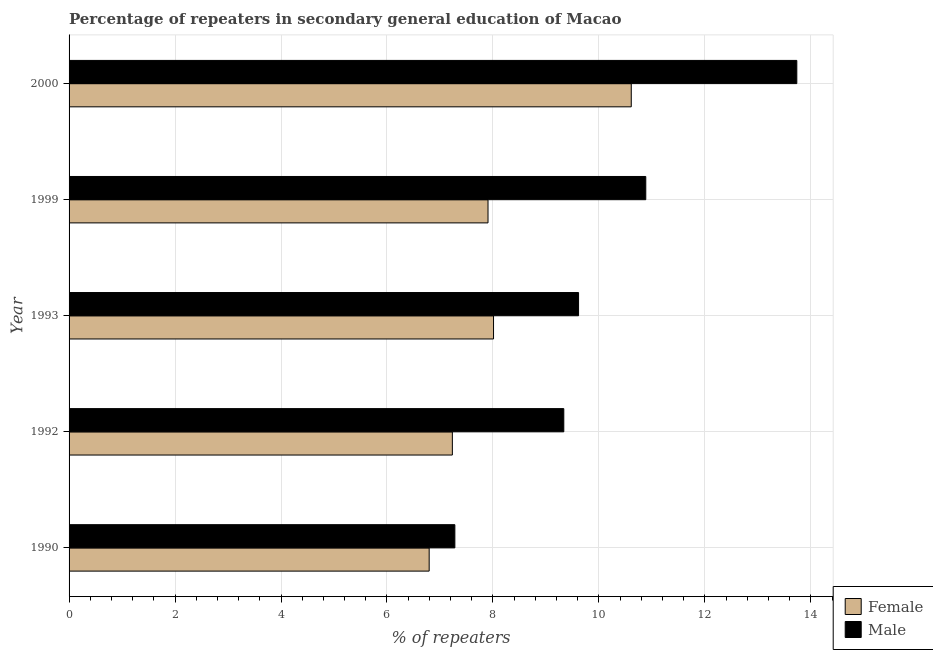How many bars are there on the 1st tick from the bottom?
Provide a short and direct response. 2. What is the percentage of male repeaters in 1990?
Provide a short and direct response. 7.28. Across all years, what is the maximum percentage of female repeaters?
Your answer should be compact. 10.61. Across all years, what is the minimum percentage of female repeaters?
Ensure brevity in your answer.  6.8. In which year was the percentage of male repeaters minimum?
Your response must be concise. 1990. What is the total percentage of male repeaters in the graph?
Your response must be concise. 50.86. What is the difference between the percentage of female repeaters in 1990 and that in 1993?
Your answer should be compact. -1.22. What is the difference between the percentage of male repeaters in 2000 and the percentage of female repeaters in 1992?
Give a very brief answer. 6.5. What is the average percentage of male repeaters per year?
Offer a terse response. 10.17. In the year 2000, what is the difference between the percentage of male repeaters and percentage of female repeaters?
Keep it short and to the point. 3.12. What is the ratio of the percentage of female repeaters in 1992 to that in 1993?
Your response must be concise. 0.9. Is the percentage of male repeaters in 1999 less than that in 2000?
Give a very brief answer. Yes. What is the difference between the highest and the second highest percentage of female repeaters?
Keep it short and to the point. 2.6. What is the difference between the highest and the lowest percentage of female repeaters?
Your response must be concise. 3.81. Is the sum of the percentage of male repeaters in 1992 and 1999 greater than the maximum percentage of female repeaters across all years?
Offer a terse response. Yes. How many bars are there?
Give a very brief answer. 10. How many years are there in the graph?
Provide a succinct answer. 5. What is the difference between two consecutive major ticks on the X-axis?
Provide a short and direct response. 2. Does the graph contain grids?
Your answer should be compact. Yes. How are the legend labels stacked?
Make the answer very short. Vertical. What is the title of the graph?
Keep it short and to the point. Percentage of repeaters in secondary general education of Macao. Does "Female" appear as one of the legend labels in the graph?
Your response must be concise. Yes. What is the label or title of the X-axis?
Your answer should be very brief. % of repeaters. What is the label or title of the Y-axis?
Ensure brevity in your answer.  Year. What is the % of repeaters of Female in 1990?
Offer a very short reply. 6.8. What is the % of repeaters in Male in 1990?
Keep it short and to the point. 7.28. What is the % of repeaters in Female in 1992?
Ensure brevity in your answer.  7.23. What is the % of repeaters in Male in 1992?
Your response must be concise. 9.34. What is the % of repeaters in Female in 1993?
Your response must be concise. 8.01. What is the % of repeaters in Male in 1993?
Give a very brief answer. 9.62. What is the % of repeaters in Female in 1999?
Your answer should be very brief. 7.91. What is the % of repeaters in Male in 1999?
Provide a short and direct response. 10.89. What is the % of repeaters in Female in 2000?
Keep it short and to the point. 10.61. What is the % of repeaters in Male in 2000?
Keep it short and to the point. 13.74. Across all years, what is the maximum % of repeaters in Female?
Keep it short and to the point. 10.61. Across all years, what is the maximum % of repeaters in Male?
Give a very brief answer. 13.74. Across all years, what is the minimum % of repeaters of Female?
Keep it short and to the point. 6.8. Across all years, what is the minimum % of repeaters of Male?
Keep it short and to the point. 7.28. What is the total % of repeaters of Female in the graph?
Your answer should be compact. 40.56. What is the total % of repeaters of Male in the graph?
Keep it short and to the point. 50.86. What is the difference between the % of repeaters in Female in 1990 and that in 1992?
Your response must be concise. -0.44. What is the difference between the % of repeaters in Male in 1990 and that in 1992?
Your answer should be very brief. -2.06. What is the difference between the % of repeaters in Female in 1990 and that in 1993?
Provide a succinct answer. -1.21. What is the difference between the % of repeaters in Male in 1990 and that in 1993?
Ensure brevity in your answer.  -2.33. What is the difference between the % of repeaters in Female in 1990 and that in 1999?
Ensure brevity in your answer.  -1.11. What is the difference between the % of repeaters in Male in 1990 and that in 1999?
Offer a terse response. -3.6. What is the difference between the % of repeaters of Female in 1990 and that in 2000?
Offer a terse response. -3.81. What is the difference between the % of repeaters in Male in 1990 and that in 2000?
Offer a terse response. -6.45. What is the difference between the % of repeaters in Female in 1992 and that in 1993?
Provide a short and direct response. -0.78. What is the difference between the % of repeaters of Male in 1992 and that in 1993?
Your answer should be compact. -0.28. What is the difference between the % of repeaters of Female in 1992 and that in 1999?
Your answer should be very brief. -0.67. What is the difference between the % of repeaters in Male in 1992 and that in 1999?
Your answer should be very brief. -1.55. What is the difference between the % of repeaters in Female in 1992 and that in 2000?
Your answer should be very brief. -3.38. What is the difference between the % of repeaters in Male in 1992 and that in 2000?
Give a very brief answer. -4.4. What is the difference between the % of repeaters of Female in 1993 and that in 1999?
Make the answer very short. 0.1. What is the difference between the % of repeaters in Male in 1993 and that in 1999?
Give a very brief answer. -1.27. What is the difference between the % of repeaters of Female in 1993 and that in 2000?
Your answer should be compact. -2.6. What is the difference between the % of repeaters in Male in 1993 and that in 2000?
Your answer should be compact. -4.12. What is the difference between the % of repeaters in Female in 1999 and that in 2000?
Give a very brief answer. -2.7. What is the difference between the % of repeaters in Male in 1999 and that in 2000?
Offer a very short reply. -2.85. What is the difference between the % of repeaters of Female in 1990 and the % of repeaters of Male in 1992?
Provide a short and direct response. -2.54. What is the difference between the % of repeaters of Female in 1990 and the % of repeaters of Male in 1993?
Your answer should be very brief. -2.82. What is the difference between the % of repeaters in Female in 1990 and the % of repeaters in Male in 1999?
Offer a very short reply. -4.09. What is the difference between the % of repeaters of Female in 1990 and the % of repeaters of Male in 2000?
Make the answer very short. -6.94. What is the difference between the % of repeaters in Female in 1992 and the % of repeaters in Male in 1993?
Your answer should be compact. -2.38. What is the difference between the % of repeaters in Female in 1992 and the % of repeaters in Male in 1999?
Your answer should be very brief. -3.65. What is the difference between the % of repeaters of Female in 1992 and the % of repeaters of Male in 2000?
Your response must be concise. -6.5. What is the difference between the % of repeaters in Female in 1993 and the % of repeaters in Male in 1999?
Offer a very short reply. -2.87. What is the difference between the % of repeaters in Female in 1993 and the % of repeaters in Male in 2000?
Your answer should be very brief. -5.72. What is the difference between the % of repeaters of Female in 1999 and the % of repeaters of Male in 2000?
Make the answer very short. -5.83. What is the average % of repeaters in Female per year?
Your answer should be compact. 8.11. What is the average % of repeaters of Male per year?
Offer a terse response. 10.17. In the year 1990, what is the difference between the % of repeaters in Female and % of repeaters in Male?
Make the answer very short. -0.48. In the year 1992, what is the difference between the % of repeaters of Female and % of repeaters of Male?
Offer a terse response. -2.1. In the year 1993, what is the difference between the % of repeaters in Female and % of repeaters in Male?
Provide a succinct answer. -1.61. In the year 1999, what is the difference between the % of repeaters in Female and % of repeaters in Male?
Offer a very short reply. -2.98. In the year 2000, what is the difference between the % of repeaters of Female and % of repeaters of Male?
Provide a short and direct response. -3.12. What is the ratio of the % of repeaters of Female in 1990 to that in 1992?
Provide a succinct answer. 0.94. What is the ratio of the % of repeaters of Male in 1990 to that in 1992?
Give a very brief answer. 0.78. What is the ratio of the % of repeaters of Female in 1990 to that in 1993?
Make the answer very short. 0.85. What is the ratio of the % of repeaters in Male in 1990 to that in 1993?
Offer a very short reply. 0.76. What is the ratio of the % of repeaters in Female in 1990 to that in 1999?
Provide a short and direct response. 0.86. What is the ratio of the % of repeaters of Male in 1990 to that in 1999?
Provide a short and direct response. 0.67. What is the ratio of the % of repeaters in Female in 1990 to that in 2000?
Your response must be concise. 0.64. What is the ratio of the % of repeaters of Male in 1990 to that in 2000?
Offer a terse response. 0.53. What is the ratio of the % of repeaters of Female in 1992 to that in 1993?
Give a very brief answer. 0.9. What is the ratio of the % of repeaters in Male in 1992 to that in 1993?
Ensure brevity in your answer.  0.97. What is the ratio of the % of repeaters in Female in 1992 to that in 1999?
Your answer should be very brief. 0.91. What is the ratio of the % of repeaters of Male in 1992 to that in 1999?
Offer a very short reply. 0.86. What is the ratio of the % of repeaters of Female in 1992 to that in 2000?
Provide a short and direct response. 0.68. What is the ratio of the % of repeaters of Male in 1992 to that in 2000?
Provide a short and direct response. 0.68. What is the ratio of the % of repeaters of Female in 1993 to that in 1999?
Give a very brief answer. 1.01. What is the ratio of the % of repeaters of Male in 1993 to that in 1999?
Offer a very short reply. 0.88. What is the ratio of the % of repeaters of Female in 1993 to that in 2000?
Provide a short and direct response. 0.76. What is the ratio of the % of repeaters in Male in 1993 to that in 2000?
Your answer should be compact. 0.7. What is the ratio of the % of repeaters in Female in 1999 to that in 2000?
Offer a terse response. 0.75. What is the ratio of the % of repeaters in Male in 1999 to that in 2000?
Ensure brevity in your answer.  0.79. What is the difference between the highest and the second highest % of repeaters in Female?
Your response must be concise. 2.6. What is the difference between the highest and the second highest % of repeaters of Male?
Give a very brief answer. 2.85. What is the difference between the highest and the lowest % of repeaters in Female?
Your response must be concise. 3.81. What is the difference between the highest and the lowest % of repeaters in Male?
Make the answer very short. 6.45. 